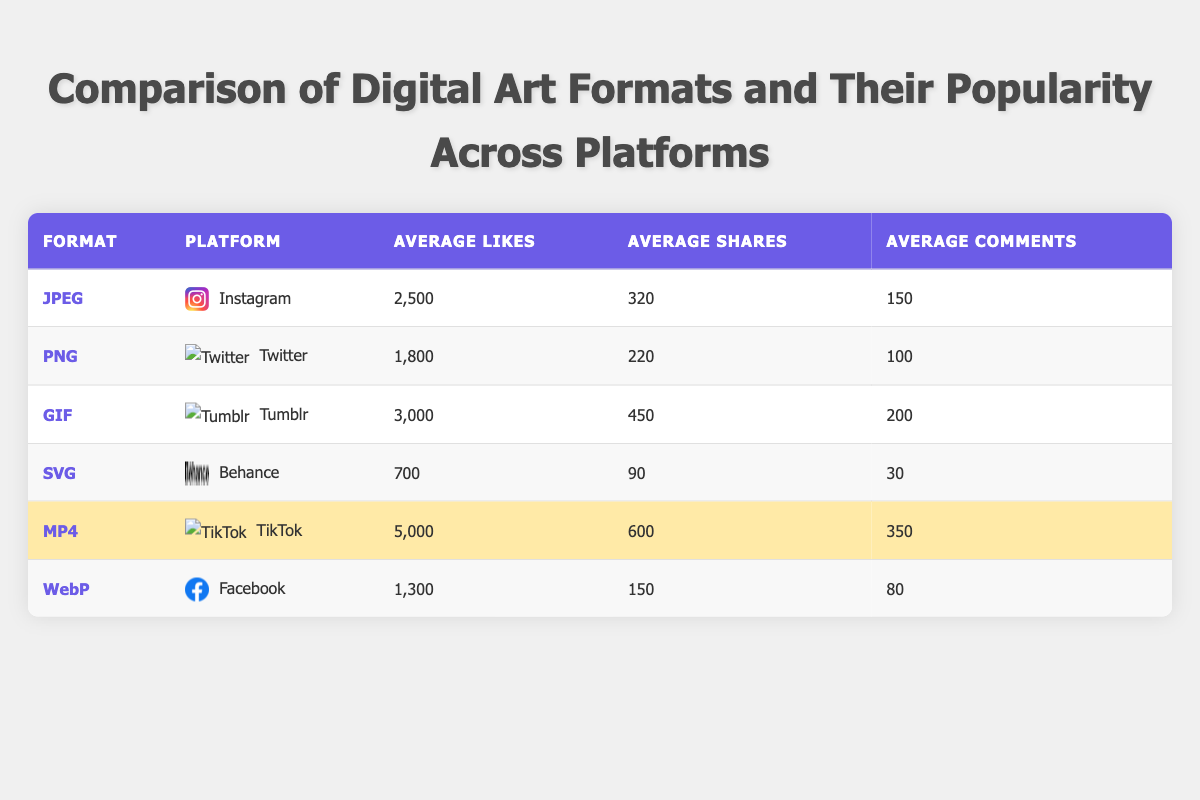What is the average number of likes for JPEG art on Instagram? The average number of likes for JPEG art on Instagram is provided directly in the table as 2500.
Answer: 2500 Which digital art format has the highest average likes? To determine which format has the highest average likes, we compare all the values in the "Average Likes" column: JPEG (2500), PNG (1800), GIF (3000), SVG (700), MP4 (5000), and WebP (1300). The highest is 5000 for MP4.
Answer: MP4 Is the average number of shares for SVG art higher than for PNG art? From the table, SVG has 90 average shares, while PNG has 220. Thus, 90 is not higher than 220 confirming that the statement is false.
Answer: No What is the total average number of comments across all formats? To find the total average number of comments, I sum the averages from each row: 150 (JPEG) + 100 (PNG) + 200 (GIF) + 30 (SVG) + 350 (MP4) + 80 (WebP) = 1010.
Answer: 1010 Which platform has the highest average shares for digital art formats? Looking at the average shares, TikTok with MP4 has 600 shares, GIF on Tumblr has 450, and JPEG on Instagram has 320. The maximum here is 600 for TikTok (MP4), which is the highest.
Answer: TikTok If you combine the average likes for JPEG and PNG, what is their total? By adding the likes for both formats: JPEG has 2500 and PNG has 1800. So, 2500 + 1800 = 4300 for their total average likes.
Answer: 4300 Is the average likes for GIF art on Tumblr greater than the combined likes for JPEG and PNG art? The average likes for GIF is 3000. The combined average likes for JPEG and PNG is calculated as 2500 + 1800 = 4300. Since 3000 is less than 4300, the statement is false.
Answer: No Which format has the lowest engagement in terms of likes, shares, and comments combined? To find this, we need to sum the likes, shares, and comments for all formats: JPEG (2500 + 320 + 150 = 2970), PNG (1800 + 220 + 100 = 2120), GIF (3000 + 450 + 200 = 3650), SVG (700 + 90 + 30 = 820), MP4 (5000 + 600 + 350 = 5950), and WebP (1300 + 150 + 80 = 1530). SVG has the lowest total of 820.
Answer: SVG 